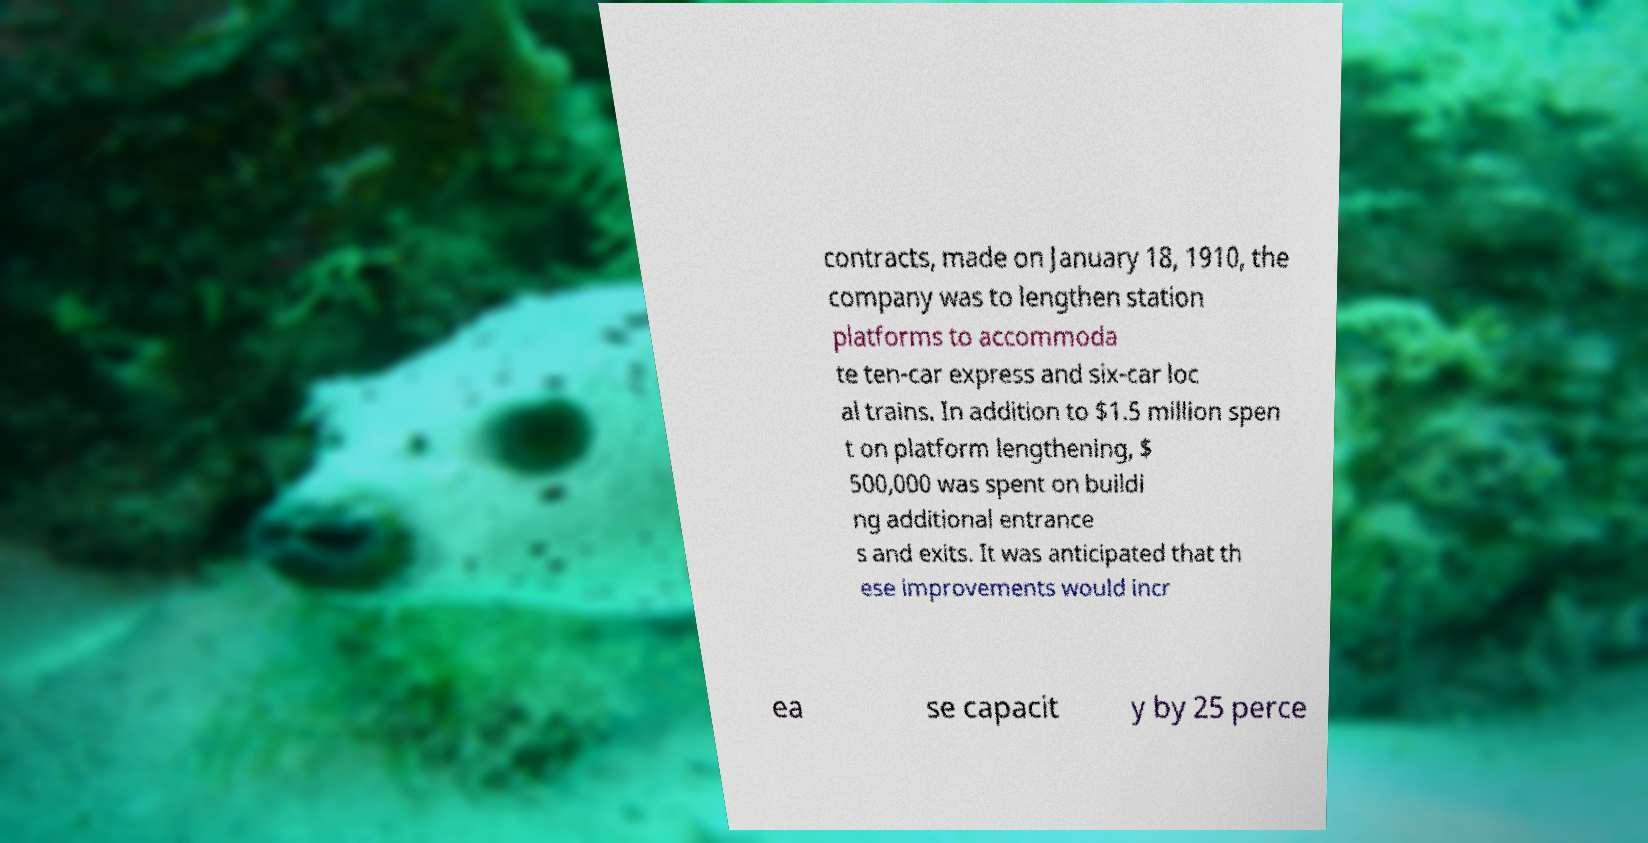Could you extract and type out the text from this image? contracts, made on January 18, 1910, the company was to lengthen station platforms to accommoda te ten-car express and six-car loc al trains. In addition to $1.5 million spen t on platform lengthening, $ 500,000 was spent on buildi ng additional entrance s and exits. It was anticipated that th ese improvements would incr ea se capacit y by 25 perce 